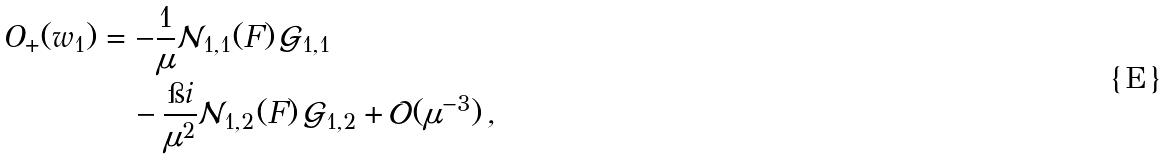<formula> <loc_0><loc_0><loc_500><loc_500>O _ { + } ( w _ { 1 } ) & = - \frac { 1 } { \mu } \mathcal { N } _ { 1 , 1 } ( F ) \, \mathcal { G } _ { 1 , 1 } \\ & \quad - \frac { \i i } { \mu ^ { 2 } } \mathcal { N } _ { 1 , 2 } ( F ) \, \mathcal { G } _ { 1 , 2 } + \mathcal { O } ( \mu ^ { - 3 } ) \, ,</formula> 